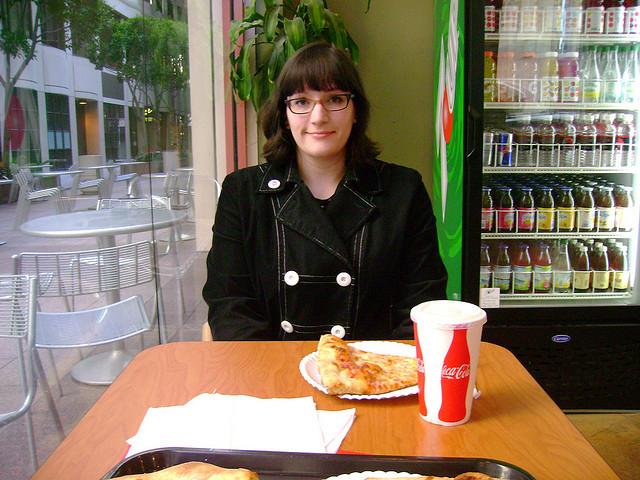What is the woman eating?
Answer briefly. Pizza. Is she happy to be eating?
Concise answer only. Yes. Is the woman eating alone?
Concise answer only. No. 